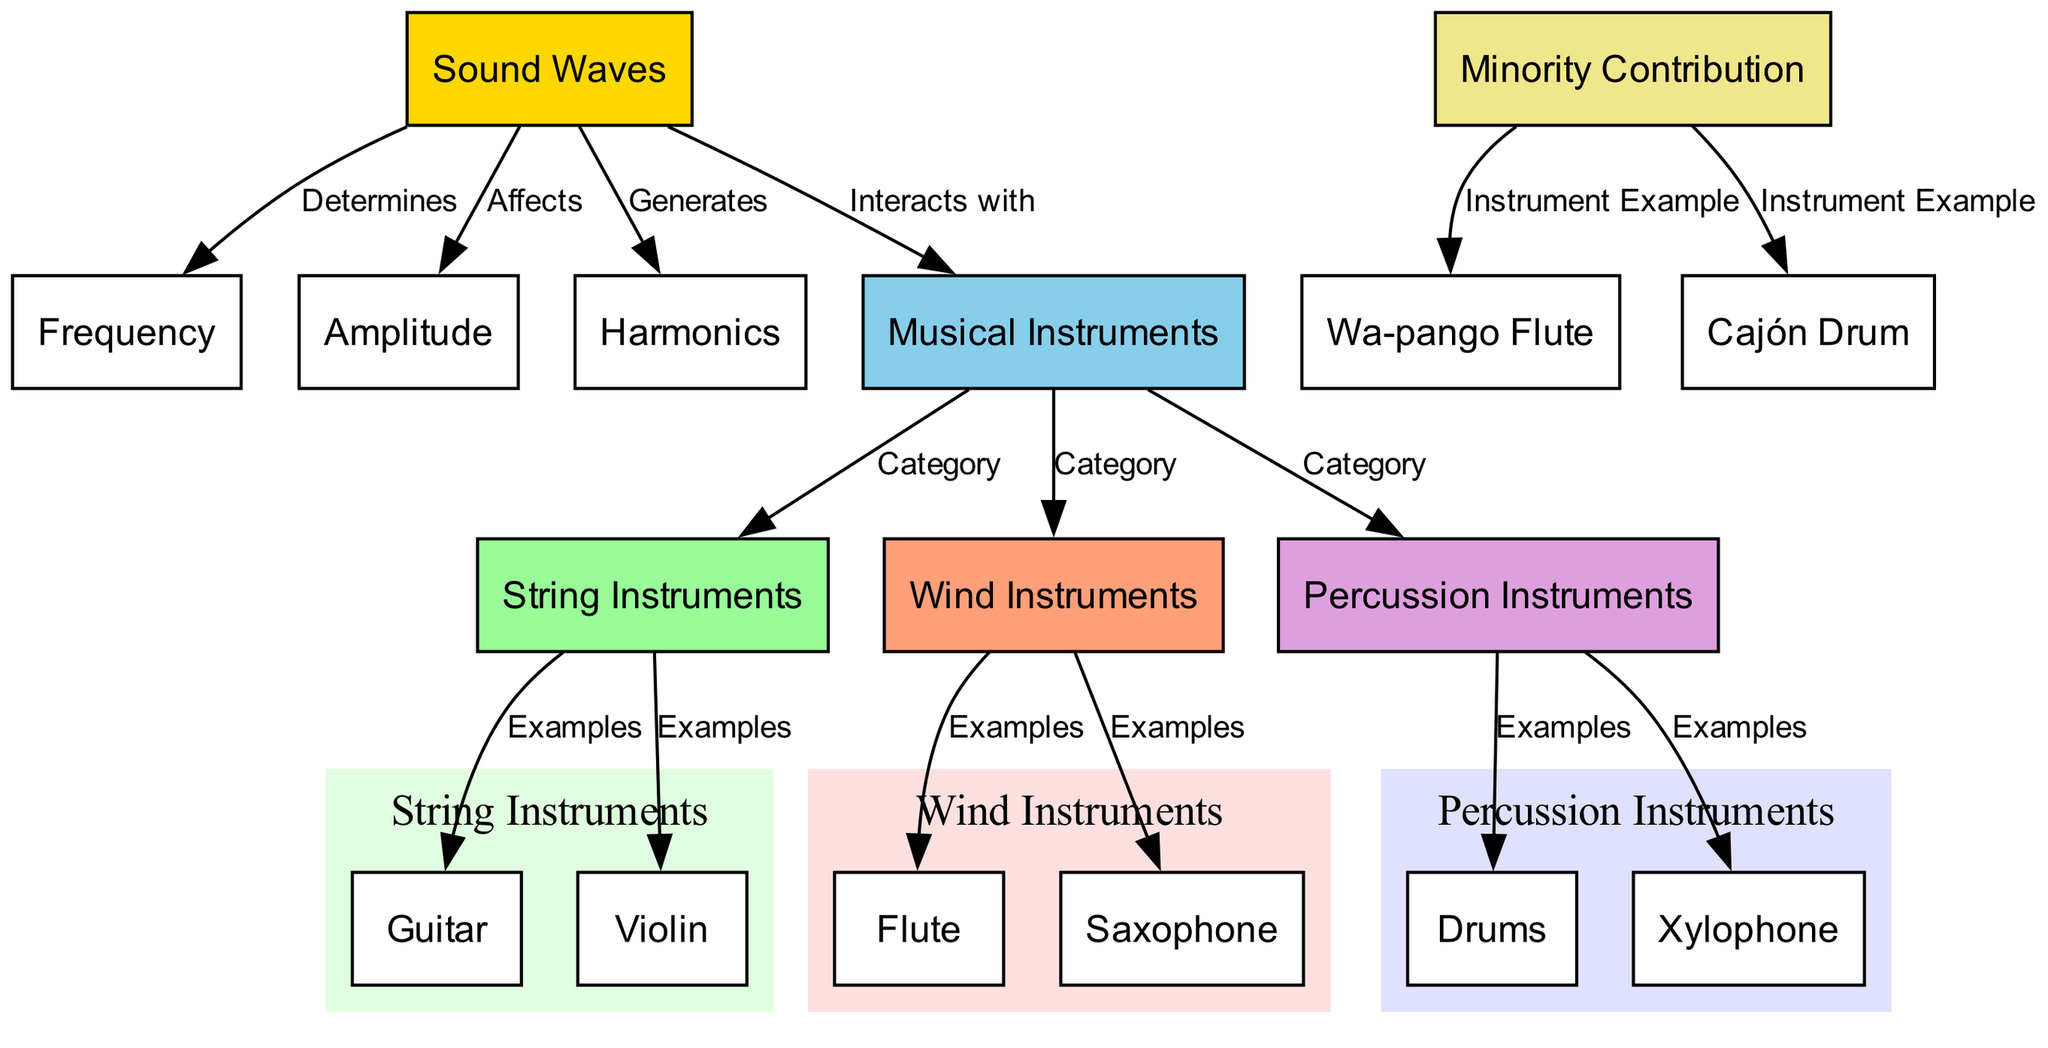What is generated by sound waves? The diagram shows that sound waves generate harmonics. This is indicated by the edge connecting the "sound_waves" node to the "harmonics" node with the label "Generates."
Answer: Harmonics How many categories of musical instruments are identified? The diagram lists three categories of musical instruments: string instruments, wind instruments, and percussion instruments. This can be counted from the edges that connect "musical_instruments" to each of these categories.
Answer: Three Which instrument is an example of a string instrument? The diagram provides examples of string instruments, and one of them is the guitar. This is indicated by the edge connecting "string_instruments" to "guitar" with the label "Examples."
Answer: Guitar What affects sound waves? According to the diagram, amplitude affects sound waves, as shown by the edge connecting "sound_waves" to "amplitude" with the label "Affects."
Answer: Amplitude What is a unique instrument example that contributes from a minority perspective? The diagram mentions the Wa-pango Flute as an example of an instrument that corresponds to minority contribution. This is shown by the edge connecting "minority_contribution" to "wapango_flute."
Answer: Wa-pango Flute Which type of instruments includes the saxophone? The diagram classifies saxophone under wind instruments. This is clearly indicated by the edge connecting "wind_instruments" to "saxophone" with the label "Examples."
Answer: Wind instruments How do sound waves interact with musical instruments? The diagram shows that sound waves interact with musical instruments, indicated by the edge connecting "sound_waves" to "musical_instruments" labeled "Interacts with."
Answer: Interacts What type of instrument is the cajón drum? The diagram categorizes the cajón drum as a percussion instrument, supported by the edge connecting "minority_contribution" to "cajon_drum" labeled "Instrument Example."
Answer: Percussion instrument What determines the frequency of sound waves? The diagram indicates that sound waves determine frequency, which is stated by the edge connecting "sound_waves" to "frequency" with the label "Determines."
Answer: Sound waves 